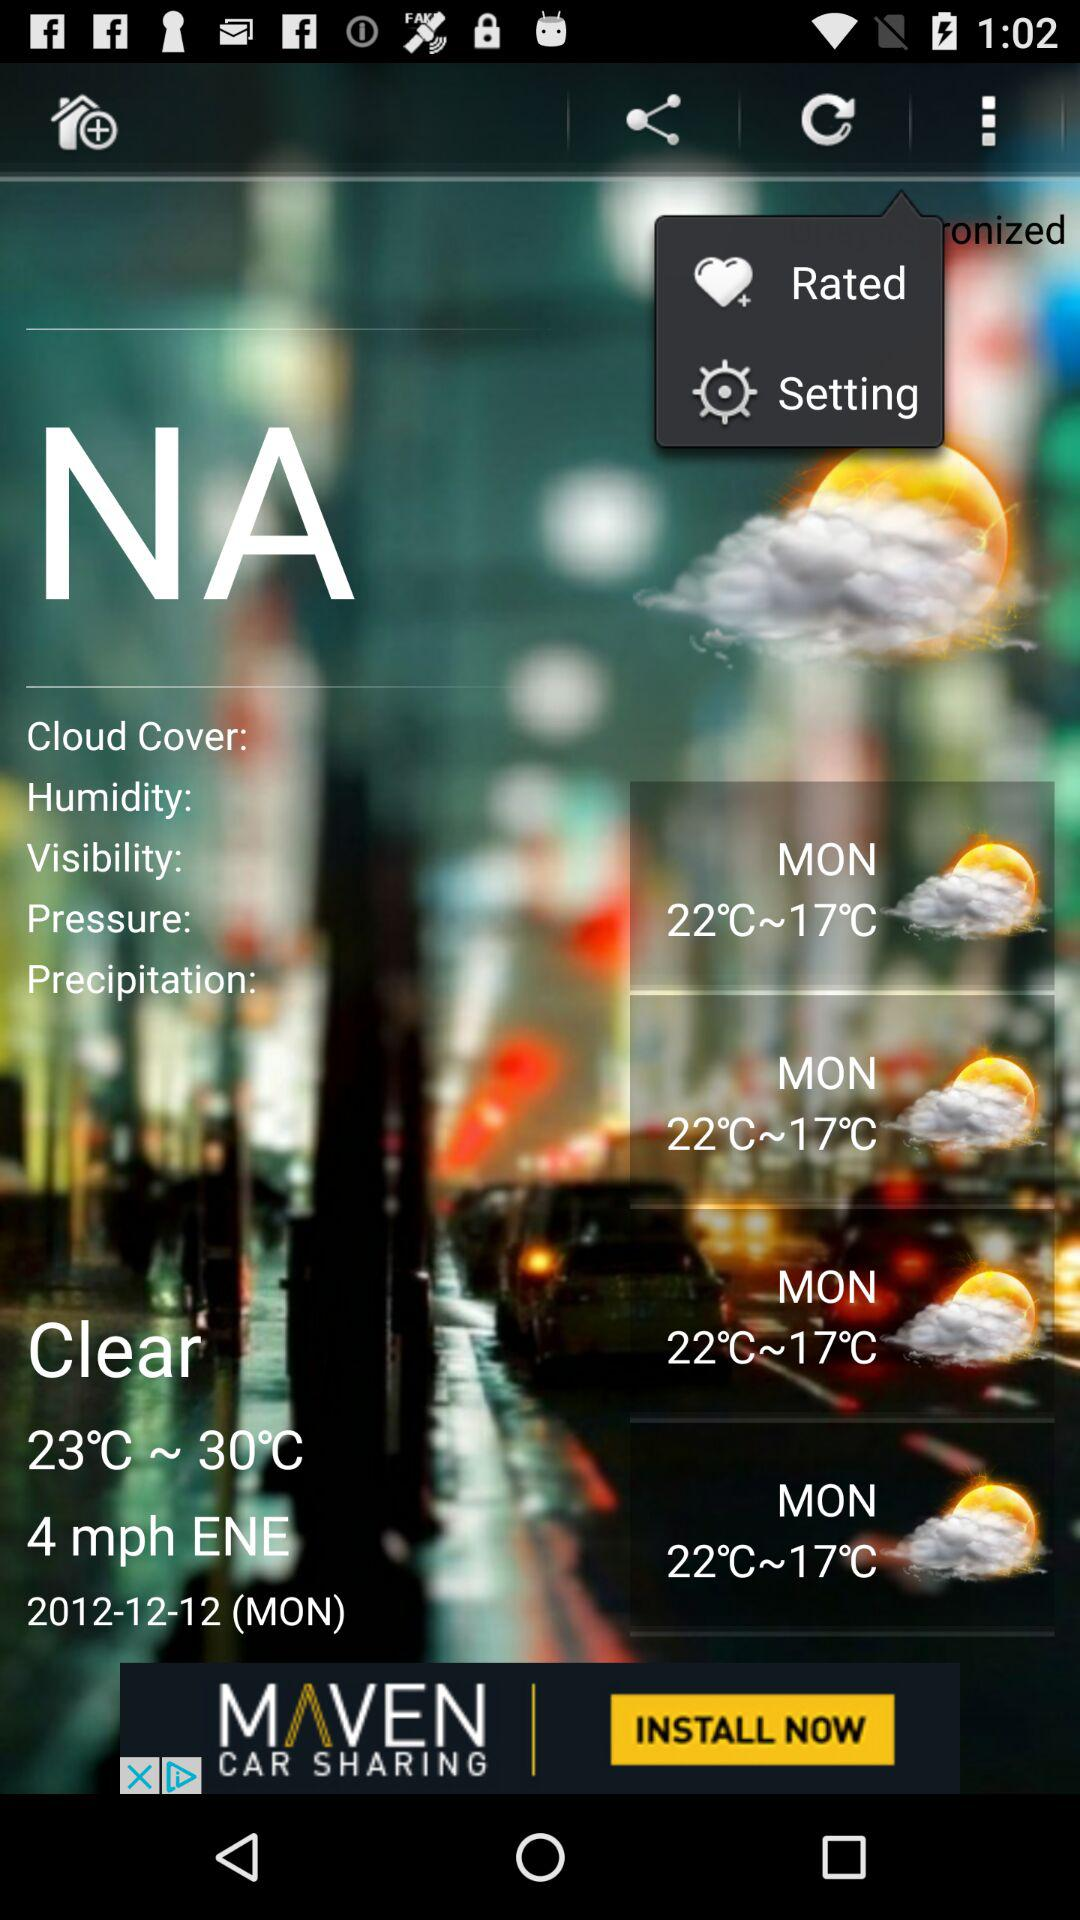What is the wind speed? The wind speed is 4 mph ENE. 